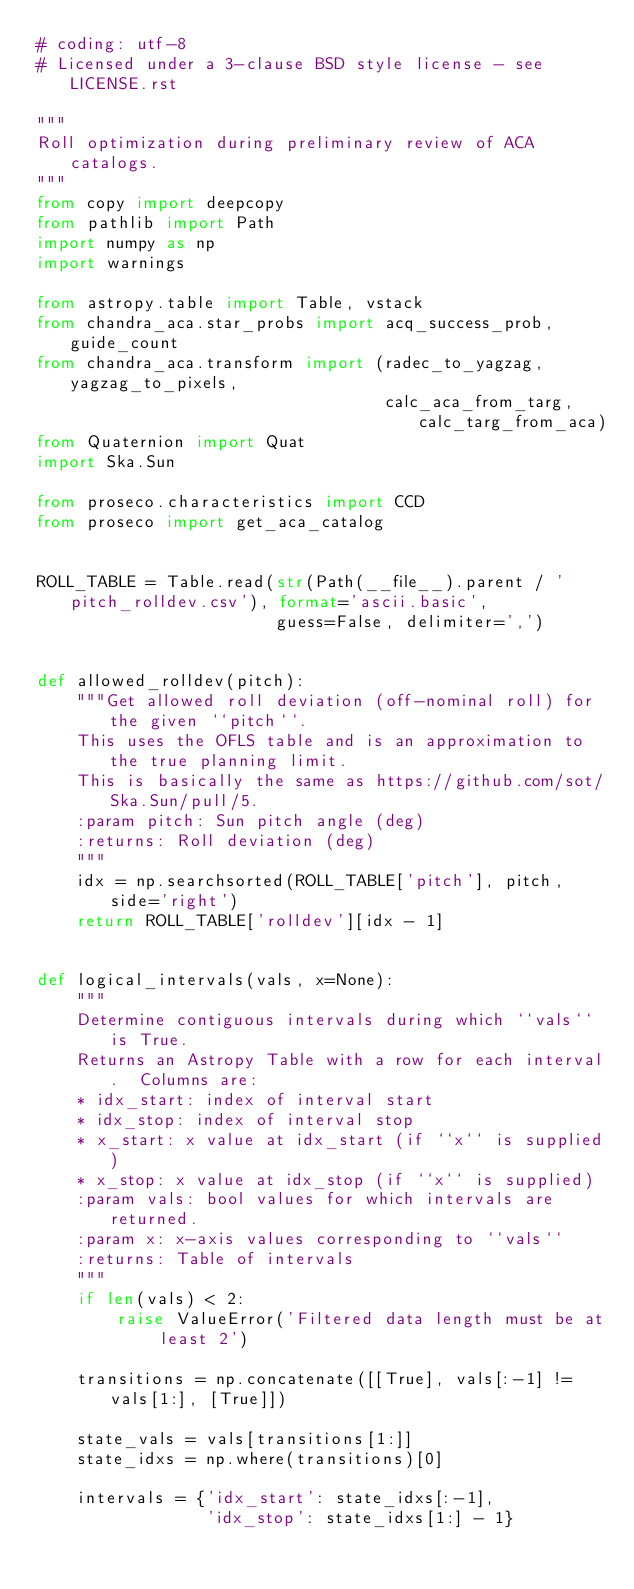Convert code to text. <code><loc_0><loc_0><loc_500><loc_500><_Python_># coding: utf-8
# Licensed under a 3-clause BSD style license - see LICENSE.rst

"""
Roll optimization during preliminary review of ACA catalogs.
"""
from copy import deepcopy
from pathlib import Path
import numpy as np
import warnings

from astropy.table import Table, vstack
from chandra_aca.star_probs import acq_success_prob, guide_count
from chandra_aca.transform import (radec_to_yagzag, yagzag_to_pixels,
                                   calc_aca_from_targ, calc_targ_from_aca)
from Quaternion import Quat
import Ska.Sun

from proseco.characteristics import CCD
from proseco import get_aca_catalog


ROLL_TABLE = Table.read(str(Path(__file__).parent / 'pitch_rolldev.csv'), format='ascii.basic',
                        guess=False, delimiter=',')


def allowed_rolldev(pitch):
    """Get allowed roll deviation (off-nominal roll) for the given ``pitch``.
    This uses the OFLS table and is an approximation to the true planning limit.
    This is basically the same as https://github.com/sot/Ska.Sun/pull/5.
    :param pitch: Sun pitch angle (deg)
    :returns: Roll deviation (deg)
    """
    idx = np.searchsorted(ROLL_TABLE['pitch'], pitch, side='right')
    return ROLL_TABLE['rolldev'][idx - 1]


def logical_intervals(vals, x=None):
    """
    Determine contiguous intervals during which ``vals`` is True.
    Returns an Astropy Table with a row for each interval.  Columns are:
    * idx_start: index of interval start
    * idx_stop: index of interval stop
    * x_start: x value at idx_start (if ``x`` is supplied)
    * x_stop: x value at idx_stop (if ``x`` is supplied)
    :param vals: bool values for which intervals are returned.
    :param x: x-axis values corresponding to ``vals``
    :returns: Table of intervals
    """
    if len(vals) < 2:
        raise ValueError('Filtered data length must be at least 2')

    transitions = np.concatenate([[True], vals[:-1] != vals[1:], [True]])

    state_vals = vals[transitions[1:]]
    state_idxs = np.where(transitions)[0]

    intervals = {'idx_start': state_idxs[:-1],
                 'idx_stop': state_idxs[1:] - 1}
</code> 